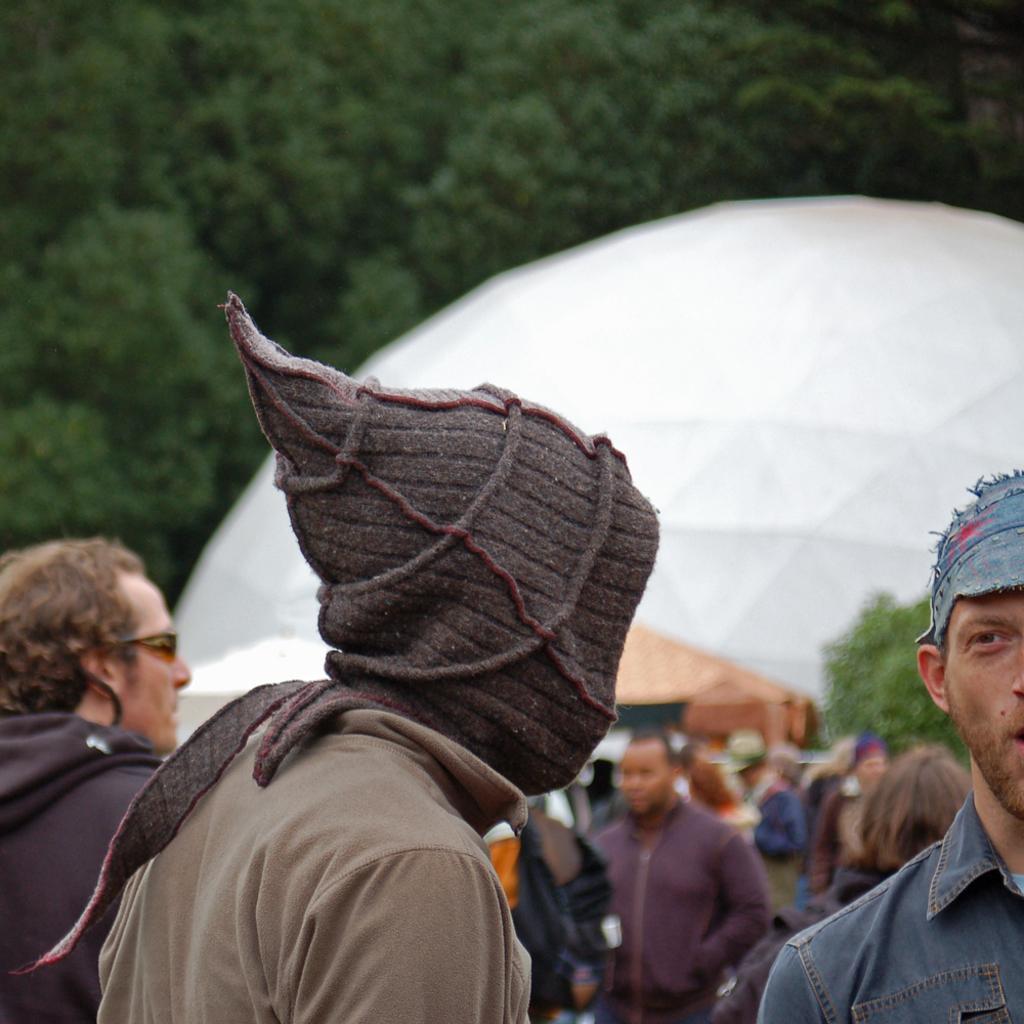Could you give a brief overview of what you see in this image? In this image, we can see a group of people. Few are wearing caps. Background we can see a blur view. Here there is a white color object and trees. 